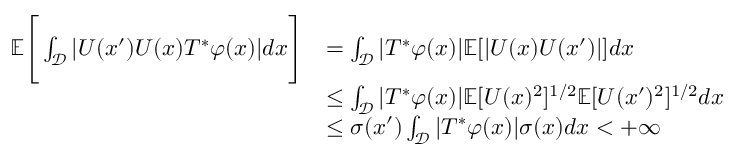<formula> <loc_0><loc_0><loc_500><loc_500>\begin{array} { r l } { \mathbb { E } \left [ \int _ { \mathcal { D } } | U ( x ^ { \prime } ) U ( x ) T ^ { * } \varphi ( x ) | d x \right ] } & { = \int _ { \mathcal { D } } | T ^ { * } \varphi ( x ) | \mathbb { E } [ | U ( x ) U ( x ^ { \prime } ) | ] d x } \\ & { \leq \int _ { \mathcal { D } } | T ^ { * } \varphi ( x ) | \mathbb { E } [ U ( x ) ^ { 2 } ] ^ { 1 / 2 } \mathbb { E } [ U ( x ^ { \prime } ) ^ { 2 } ] ^ { 1 / 2 } d x } \\ & { \leq \sigma ( x ^ { \prime } ) \int _ { \mathcal { D } } | T ^ { * } \varphi ( x ) | \sigma ( x ) d x < + \infty } \end{array}</formula> 